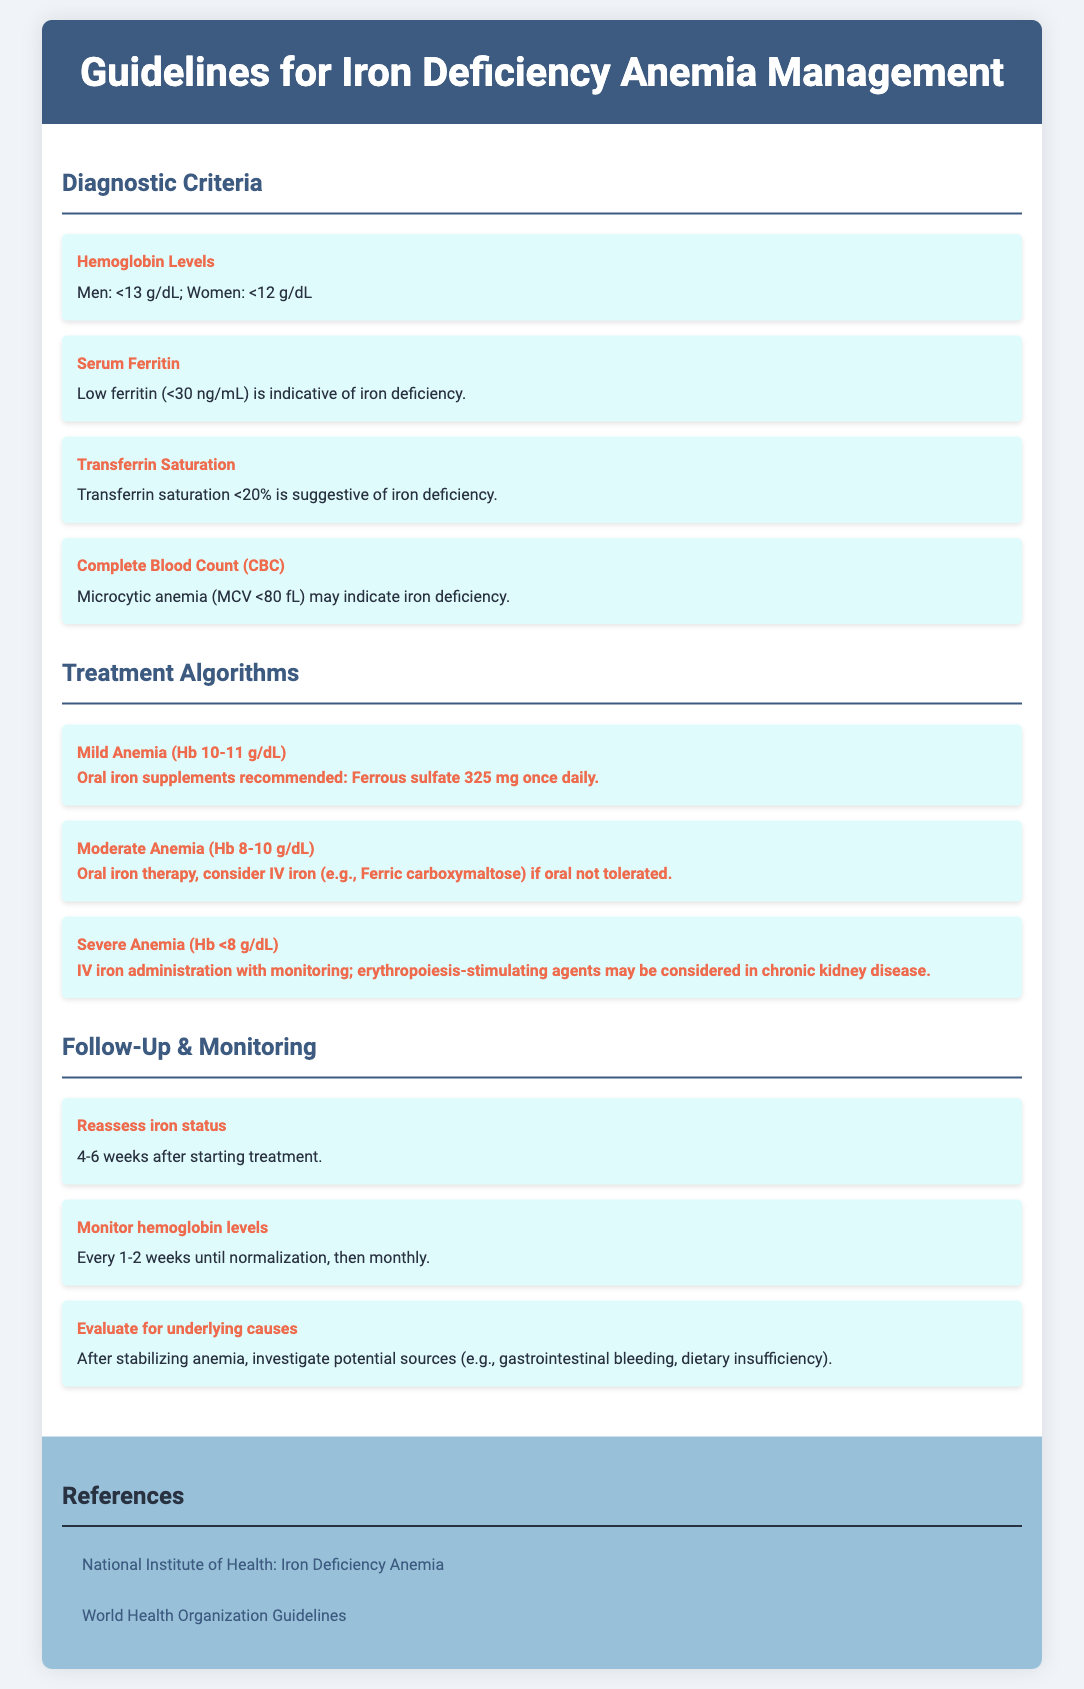What are the hemoglobin levels indicating mild anemia? Mild anemia is defined by hemoglobin levels between 10 to 11 g/dL as stated in the treatment algorithms.
Answer: 10-11 g/dL What is the serum ferritin level that indicates iron deficiency? A low ferritin level of less than 30 ng/mL is indicative of iron deficiency according to the diagnostic criteria.
Answer: <30 ng/mL What is the recommended oral iron supplement dosage for mild anemia? The document states that for mild anemia, the recommended dosage is ferrous sulfate 325 mg once daily.
Answer: Ferrous sulfate 325 mg once daily What transferrin saturation percentage suggests iron deficiency? Transferrin saturation less than 20% suggests iron deficiency as per the diagnostic criteria.
Answer: <20% When should iron status be reassessed after starting treatment? The guidelines recommend reassessing iron status 4-6 weeks after starting treatment.
Answer: 4-6 weeks What hemoglobin level is categorized as severe anemia? Severe anemia is defined as a hemoglobin level less than 8 g/dL according to the treatment algorithms.
Answer: <8 g/dL What should be monitored every 1-2 weeks until normalization? Hemoglobin levels should be monitored every 1-2 weeks until normalization as indicated in the follow-up section.
Answer: Hemoglobin levels Which organization provides guidelines on iron deficiency anemia? The document references the National Institute of Health as one of the organizations providing guidelines.
Answer: National Institute of Health 